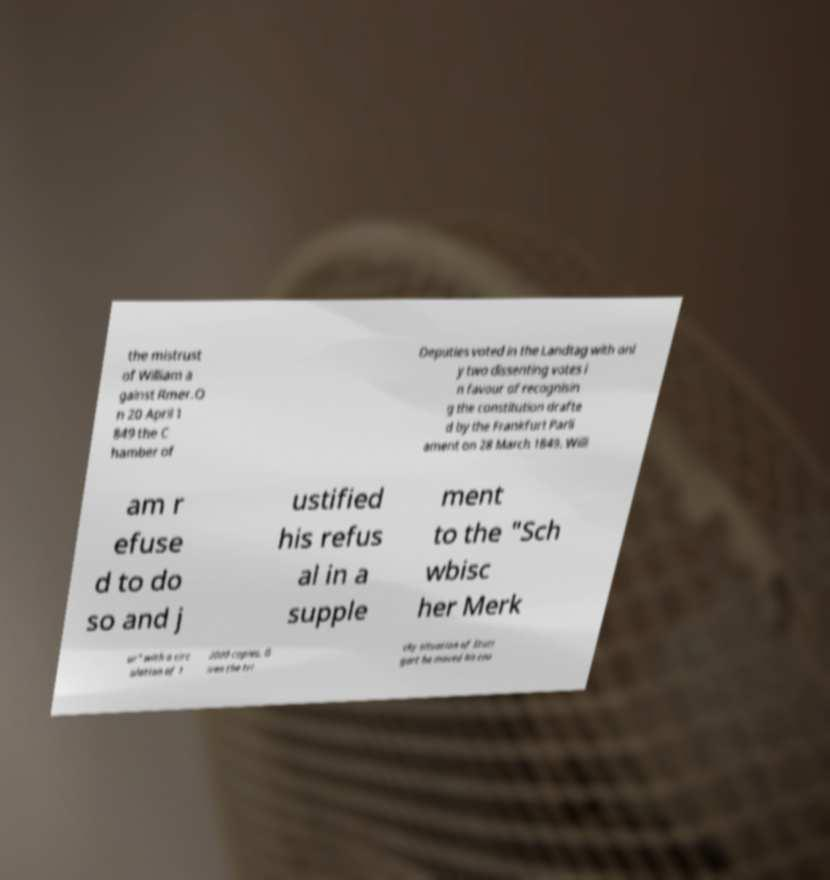Please identify and transcribe the text found in this image. the mistrust of William a gainst Rmer.O n 20 April 1 849 the C hamber of Deputies voted in the Landtag with onl y two dissenting votes i n favour of recognisin g the constitution drafte d by the Frankfurt Parli ament on 28 March 1849. Willi am r efuse d to do so and j ustified his refus al in a supple ment to the "Sch wbisc her Merk ur" with a circ ulation of 1 2000 copies. G iven the tri cky situation of Stutt gart he moved his cou 